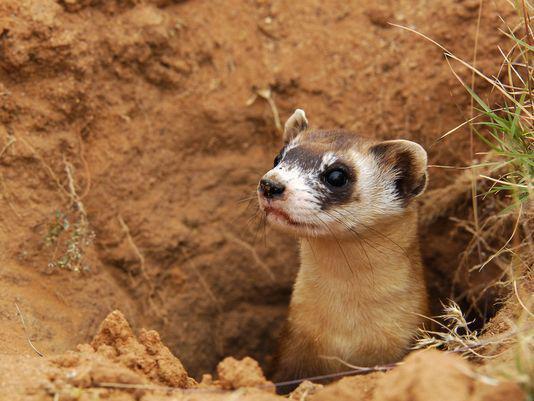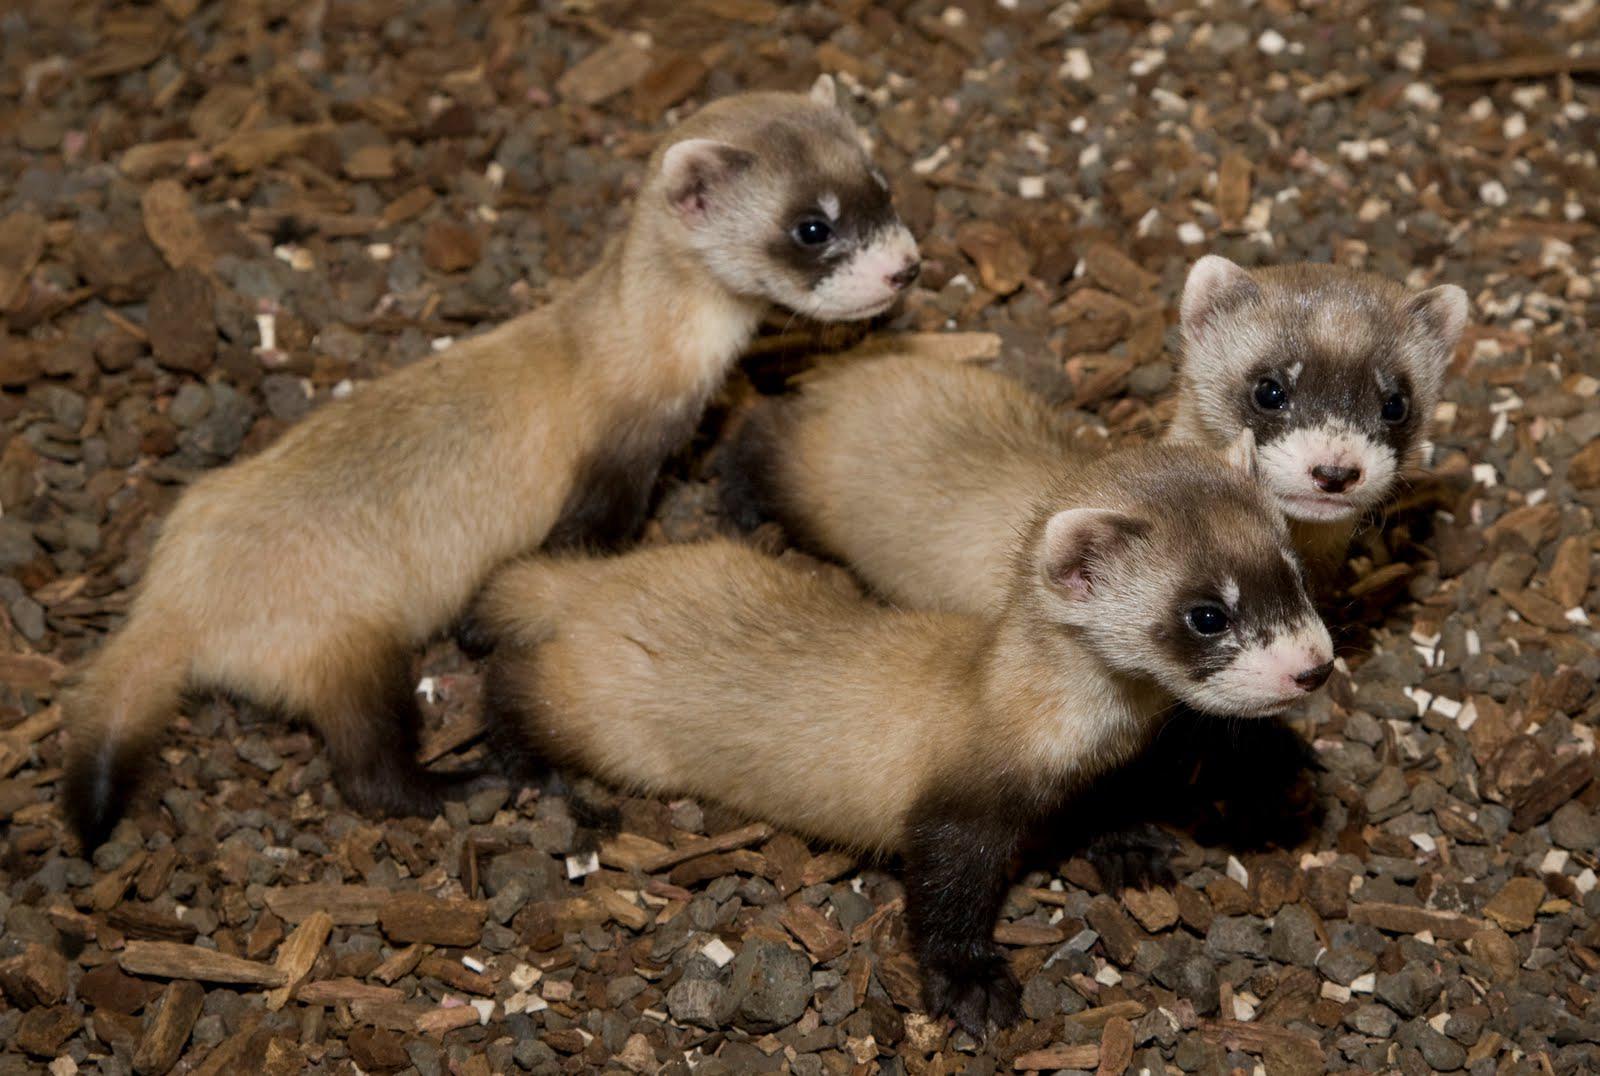The first image is the image on the left, the second image is the image on the right. Assess this claim about the two images: "The images contain a total of four ferrets.". Correct or not? Answer yes or no. Yes. The first image is the image on the left, the second image is the image on the right. Given the left and right images, does the statement "There are no more than three ferrets" hold true? Answer yes or no. No. 